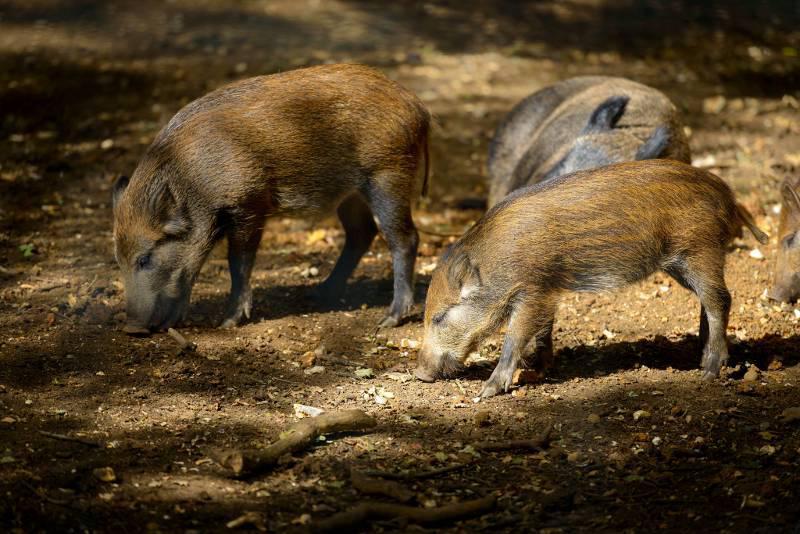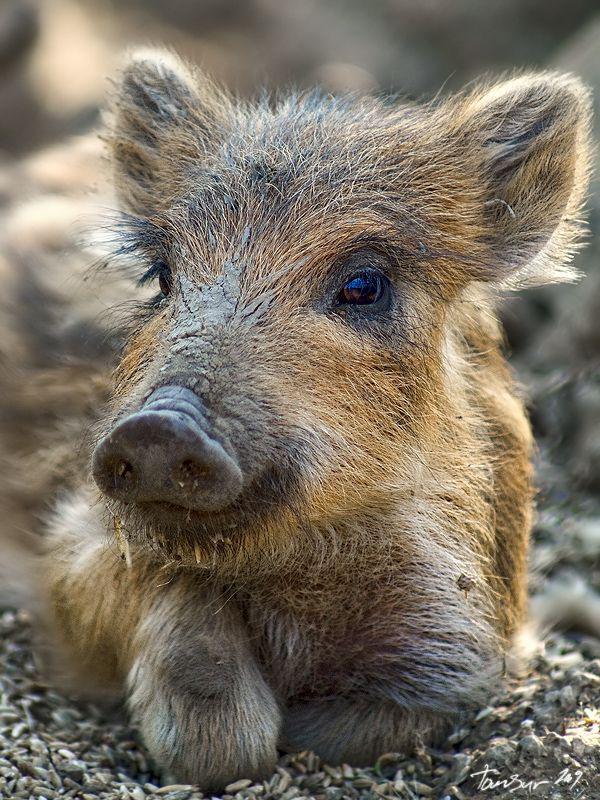The first image is the image on the left, the second image is the image on the right. Considering the images on both sides, is "A single animal is standing on the ground in the image on the right." valid? Answer yes or no. No. 